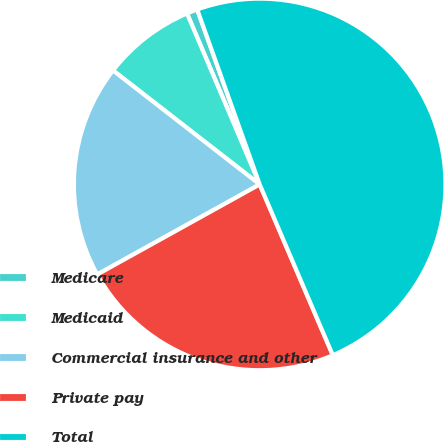<chart> <loc_0><loc_0><loc_500><loc_500><pie_chart><fcel>Medicare<fcel>Medicaid<fcel>Commercial insurance and other<fcel>Private pay<fcel>Total<nl><fcel>0.94%<fcel>8.09%<fcel>18.57%<fcel>23.38%<fcel>49.02%<nl></chart> 